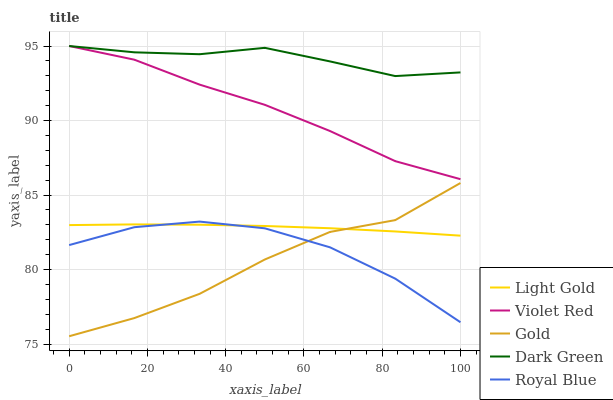Does Gold have the minimum area under the curve?
Answer yes or no. Yes. Does Dark Green have the maximum area under the curve?
Answer yes or no. Yes. Does Violet Red have the minimum area under the curve?
Answer yes or no. No. Does Violet Red have the maximum area under the curve?
Answer yes or no. No. Is Light Gold the smoothest?
Answer yes or no. Yes. Is Gold the roughest?
Answer yes or no. Yes. Is Violet Red the smoothest?
Answer yes or no. No. Is Violet Red the roughest?
Answer yes or no. No. Does Violet Red have the lowest value?
Answer yes or no. No. Does Light Gold have the highest value?
Answer yes or no. No. Is Gold less than Dark Green?
Answer yes or no. Yes. Is Dark Green greater than Royal Blue?
Answer yes or no. Yes. Does Gold intersect Dark Green?
Answer yes or no. No. 